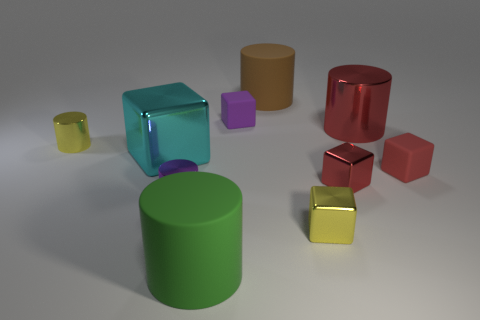There is a red block that is to the left of the metal cylinder that is on the right side of the small matte thing on the left side of the big red metal thing; what is its size?
Offer a very short reply. Small. Are there more yellow things than small cyan matte cubes?
Your answer should be compact. Yes. There is a rubber cylinder that is behind the small yellow metal block; is its color the same as the tiny block that is to the left of the large brown thing?
Keep it short and to the point. No. Is the material of the small purple object that is behind the small yellow cylinder the same as the tiny yellow thing in front of the yellow shiny cylinder?
Your answer should be very brief. No. How many yellow cylinders are the same size as the green cylinder?
Keep it short and to the point. 0. Is the number of big cyan cylinders less than the number of purple blocks?
Keep it short and to the point. Yes. There is a tiny yellow metal thing to the left of the yellow object that is in front of the big cube; what shape is it?
Keep it short and to the point. Cylinder. What is the shape of the red rubber object that is the same size as the yellow metallic block?
Ensure brevity in your answer.  Cube. Are there any big brown things that have the same shape as the purple metal object?
Keep it short and to the point. Yes. What material is the purple block?
Provide a short and direct response. Rubber. 